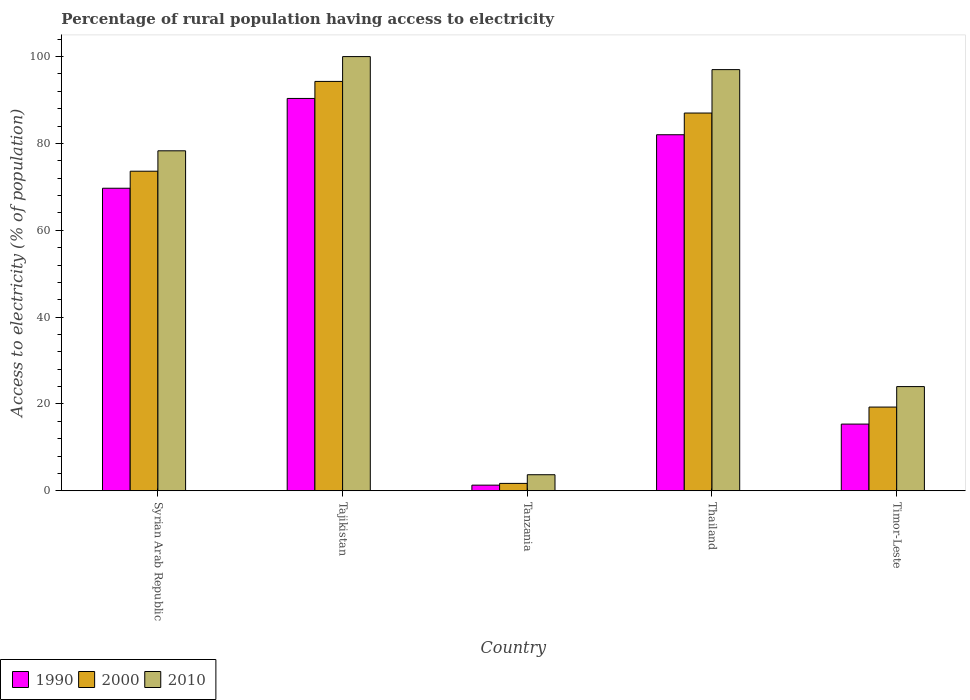How many different coloured bars are there?
Ensure brevity in your answer.  3. How many groups of bars are there?
Make the answer very short. 5. Are the number of bars on each tick of the X-axis equal?
Give a very brief answer. Yes. What is the label of the 1st group of bars from the left?
Offer a terse response. Syrian Arab Republic. In how many cases, is the number of bars for a given country not equal to the number of legend labels?
Your answer should be very brief. 0. What is the percentage of rural population having access to electricity in 2000 in Tajikistan?
Provide a short and direct response. 94.28. Across all countries, what is the maximum percentage of rural population having access to electricity in 1990?
Provide a succinct answer. 90.36. Across all countries, what is the minimum percentage of rural population having access to electricity in 2010?
Offer a very short reply. 3.7. In which country was the percentage of rural population having access to electricity in 2010 maximum?
Provide a short and direct response. Tajikistan. In which country was the percentage of rural population having access to electricity in 2010 minimum?
Ensure brevity in your answer.  Tanzania. What is the total percentage of rural population having access to electricity in 2010 in the graph?
Your answer should be compact. 303. What is the difference between the percentage of rural population having access to electricity in 2010 in Syrian Arab Republic and that in Tanzania?
Your answer should be very brief. 74.6. What is the difference between the percentage of rural population having access to electricity in 2010 in Timor-Leste and the percentage of rural population having access to electricity in 2000 in Syrian Arab Republic?
Your answer should be very brief. -49.6. What is the average percentage of rural population having access to electricity in 2010 per country?
Provide a succinct answer. 60.6. What is the difference between the percentage of rural population having access to electricity of/in 2010 and percentage of rural population having access to electricity of/in 1990 in Tanzania?
Your response must be concise. 2.4. In how many countries, is the percentage of rural population having access to electricity in 2010 greater than 8 %?
Provide a short and direct response. 4. What is the ratio of the percentage of rural population having access to electricity in 2010 in Thailand to that in Timor-Leste?
Ensure brevity in your answer.  4.04. What is the difference between the highest and the second highest percentage of rural population having access to electricity in 2000?
Make the answer very short. -20.68. What is the difference between the highest and the lowest percentage of rural population having access to electricity in 2000?
Keep it short and to the point. 92.58. In how many countries, is the percentage of rural population having access to electricity in 2010 greater than the average percentage of rural population having access to electricity in 2010 taken over all countries?
Your response must be concise. 3. Is the sum of the percentage of rural population having access to electricity in 1990 in Syrian Arab Republic and Timor-Leste greater than the maximum percentage of rural population having access to electricity in 2010 across all countries?
Provide a succinct answer. No. What does the 2nd bar from the right in Syrian Arab Republic represents?
Keep it short and to the point. 2000. Is it the case that in every country, the sum of the percentage of rural population having access to electricity in 1990 and percentage of rural population having access to electricity in 2010 is greater than the percentage of rural population having access to electricity in 2000?
Offer a terse response. Yes. How many countries are there in the graph?
Make the answer very short. 5. What is the difference between two consecutive major ticks on the Y-axis?
Your answer should be compact. 20. Are the values on the major ticks of Y-axis written in scientific E-notation?
Provide a short and direct response. No. Does the graph contain any zero values?
Give a very brief answer. No. Where does the legend appear in the graph?
Offer a terse response. Bottom left. How many legend labels are there?
Provide a succinct answer. 3. How are the legend labels stacked?
Ensure brevity in your answer.  Horizontal. What is the title of the graph?
Offer a terse response. Percentage of rural population having access to electricity. What is the label or title of the Y-axis?
Your answer should be very brief. Access to electricity (% of population). What is the Access to electricity (% of population) of 1990 in Syrian Arab Republic?
Your answer should be compact. 69.68. What is the Access to electricity (% of population) in 2000 in Syrian Arab Republic?
Make the answer very short. 73.6. What is the Access to electricity (% of population) in 2010 in Syrian Arab Republic?
Your answer should be compact. 78.3. What is the Access to electricity (% of population) of 1990 in Tajikistan?
Give a very brief answer. 90.36. What is the Access to electricity (% of population) of 2000 in Tajikistan?
Give a very brief answer. 94.28. What is the Access to electricity (% of population) in 2010 in Tajikistan?
Offer a very short reply. 100. What is the Access to electricity (% of population) in 2010 in Tanzania?
Provide a succinct answer. 3.7. What is the Access to electricity (% of population) of 2000 in Thailand?
Provide a succinct answer. 87. What is the Access to electricity (% of population) of 2010 in Thailand?
Your answer should be compact. 97. What is the Access to electricity (% of population) in 1990 in Timor-Leste?
Your response must be concise. 15.36. What is the Access to electricity (% of population) in 2000 in Timor-Leste?
Offer a terse response. 19.28. Across all countries, what is the maximum Access to electricity (% of population) in 1990?
Make the answer very short. 90.36. Across all countries, what is the maximum Access to electricity (% of population) of 2000?
Keep it short and to the point. 94.28. Across all countries, what is the maximum Access to electricity (% of population) in 2010?
Your answer should be compact. 100. Across all countries, what is the minimum Access to electricity (% of population) of 1990?
Offer a very short reply. 1.3. Across all countries, what is the minimum Access to electricity (% of population) in 2010?
Your answer should be very brief. 3.7. What is the total Access to electricity (% of population) of 1990 in the graph?
Offer a very short reply. 258.7. What is the total Access to electricity (% of population) of 2000 in the graph?
Your answer should be compact. 275.86. What is the total Access to electricity (% of population) of 2010 in the graph?
Your answer should be compact. 303. What is the difference between the Access to electricity (% of population) of 1990 in Syrian Arab Republic and that in Tajikistan?
Offer a very short reply. -20.68. What is the difference between the Access to electricity (% of population) in 2000 in Syrian Arab Republic and that in Tajikistan?
Make the answer very short. -20.68. What is the difference between the Access to electricity (% of population) in 2010 in Syrian Arab Republic and that in Tajikistan?
Give a very brief answer. -21.7. What is the difference between the Access to electricity (% of population) of 1990 in Syrian Arab Republic and that in Tanzania?
Offer a very short reply. 68.38. What is the difference between the Access to electricity (% of population) in 2000 in Syrian Arab Republic and that in Tanzania?
Keep it short and to the point. 71.9. What is the difference between the Access to electricity (% of population) of 2010 in Syrian Arab Republic and that in Tanzania?
Make the answer very short. 74.6. What is the difference between the Access to electricity (% of population) of 1990 in Syrian Arab Republic and that in Thailand?
Give a very brief answer. -12.32. What is the difference between the Access to electricity (% of population) of 2000 in Syrian Arab Republic and that in Thailand?
Provide a short and direct response. -13.4. What is the difference between the Access to electricity (% of population) in 2010 in Syrian Arab Republic and that in Thailand?
Give a very brief answer. -18.7. What is the difference between the Access to electricity (% of population) in 1990 in Syrian Arab Republic and that in Timor-Leste?
Provide a succinct answer. 54.32. What is the difference between the Access to electricity (% of population) in 2000 in Syrian Arab Republic and that in Timor-Leste?
Keep it short and to the point. 54.32. What is the difference between the Access to electricity (% of population) in 2010 in Syrian Arab Republic and that in Timor-Leste?
Offer a terse response. 54.3. What is the difference between the Access to electricity (% of population) of 1990 in Tajikistan and that in Tanzania?
Offer a very short reply. 89.06. What is the difference between the Access to electricity (% of population) of 2000 in Tajikistan and that in Tanzania?
Your answer should be compact. 92.58. What is the difference between the Access to electricity (% of population) of 2010 in Tajikistan and that in Tanzania?
Provide a succinct answer. 96.3. What is the difference between the Access to electricity (% of population) of 1990 in Tajikistan and that in Thailand?
Your answer should be very brief. 8.36. What is the difference between the Access to electricity (% of population) in 2000 in Tajikistan and that in Thailand?
Provide a succinct answer. 7.28. What is the difference between the Access to electricity (% of population) of 2000 in Tajikistan and that in Timor-Leste?
Your answer should be compact. 75. What is the difference between the Access to electricity (% of population) in 1990 in Tanzania and that in Thailand?
Offer a very short reply. -80.7. What is the difference between the Access to electricity (% of population) of 2000 in Tanzania and that in Thailand?
Provide a short and direct response. -85.3. What is the difference between the Access to electricity (% of population) of 2010 in Tanzania and that in Thailand?
Keep it short and to the point. -93.3. What is the difference between the Access to electricity (% of population) in 1990 in Tanzania and that in Timor-Leste?
Your answer should be compact. -14.06. What is the difference between the Access to electricity (% of population) in 2000 in Tanzania and that in Timor-Leste?
Offer a very short reply. -17.58. What is the difference between the Access to electricity (% of population) of 2010 in Tanzania and that in Timor-Leste?
Your response must be concise. -20.3. What is the difference between the Access to electricity (% of population) of 1990 in Thailand and that in Timor-Leste?
Offer a terse response. 66.64. What is the difference between the Access to electricity (% of population) in 2000 in Thailand and that in Timor-Leste?
Give a very brief answer. 67.72. What is the difference between the Access to electricity (% of population) of 2010 in Thailand and that in Timor-Leste?
Make the answer very short. 73. What is the difference between the Access to electricity (% of population) in 1990 in Syrian Arab Republic and the Access to electricity (% of population) in 2000 in Tajikistan?
Provide a succinct answer. -24.6. What is the difference between the Access to electricity (% of population) of 1990 in Syrian Arab Republic and the Access to electricity (% of population) of 2010 in Tajikistan?
Your answer should be compact. -30.32. What is the difference between the Access to electricity (% of population) of 2000 in Syrian Arab Republic and the Access to electricity (% of population) of 2010 in Tajikistan?
Offer a terse response. -26.4. What is the difference between the Access to electricity (% of population) in 1990 in Syrian Arab Republic and the Access to electricity (% of population) in 2000 in Tanzania?
Your response must be concise. 67.98. What is the difference between the Access to electricity (% of population) of 1990 in Syrian Arab Republic and the Access to electricity (% of population) of 2010 in Tanzania?
Your answer should be compact. 65.98. What is the difference between the Access to electricity (% of population) in 2000 in Syrian Arab Republic and the Access to electricity (% of population) in 2010 in Tanzania?
Offer a very short reply. 69.9. What is the difference between the Access to electricity (% of population) of 1990 in Syrian Arab Republic and the Access to electricity (% of population) of 2000 in Thailand?
Your answer should be very brief. -17.32. What is the difference between the Access to electricity (% of population) in 1990 in Syrian Arab Republic and the Access to electricity (% of population) in 2010 in Thailand?
Offer a terse response. -27.32. What is the difference between the Access to electricity (% of population) in 2000 in Syrian Arab Republic and the Access to electricity (% of population) in 2010 in Thailand?
Your answer should be compact. -23.4. What is the difference between the Access to electricity (% of population) of 1990 in Syrian Arab Republic and the Access to electricity (% of population) of 2000 in Timor-Leste?
Keep it short and to the point. 50.4. What is the difference between the Access to electricity (% of population) of 1990 in Syrian Arab Republic and the Access to electricity (% of population) of 2010 in Timor-Leste?
Offer a terse response. 45.68. What is the difference between the Access to electricity (% of population) of 2000 in Syrian Arab Republic and the Access to electricity (% of population) of 2010 in Timor-Leste?
Provide a succinct answer. 49.6. What is the difference between the Access to electricity (% of population) in 1990 in Tajikistan and the Access to electricity (% of population) in 2000 in Tanzania?
Your response must be concise. 88.66. What is the difference between the Access to electricity (% of population) of 1990 in Tajikistan and the Access to electricity (% of population) of 2010 in Tanzania?
Make the answer very short. 86.66. What is the difference between the Access to electricity (% of population) in 2000 in Tajikistan and the Access to electricity (% of population) in 2010 in Tanzania?
Your response must be concise. 90.58. What is the difference between the Access to electricity (% of population) of 1990 in Tajikistan and the Access to electricity (% of population) of 2000 in Thailand?
Keep it short and to the point. 3.36. What is the difference between the Access to electricity (% of population) of 1990 in Tajikistan and the Access to electricity (% of population) of 2010 in Thailand?
Give a very brief answer. -6.64. What is the difference between the Access to electricity (% of population) of 2000 in Tajikistan and the Access to electricity (% of population) of 2010 in Thailand?
Your answer should be compact. -2.72. What is the difference between the Access to electricity (% of population) of 1990 in Tajikistan and the Access to electricity (% of population) of 2000 in Timor-Leste?
Ensure brevity in your answer.  71.08. What is the difference between the Access to electricity (% of population) in 1990 in Tajikistan and the Access to electricity (% of population) in 2010 in Timor-Leste?
Your answer should be compact. 66.36. What is the difference between the Access to electricity (% of population) of 2000 in Tajikistan and the Access to electricity (% of population) of 2010 in Timor-Leste?
Offer a terse response. 70.28. What is the difference between the Access to electricity (% of population) of 1990 in Tanzania and the Access to electricity (% of population) of 2000 in Thailand?
Offer a terse response. -85.7. What is the difference between the Access to electricity (% of population) in 1990 in Tanzania and the Access to electricity (% of population) in 2010 in Thailand?
Ensure brevity in your answer.  -95.7. What is the difference between the Access to electricity (% of population) of 2000 in Tanzania and the Access to electricity (% of population) of 2010 in Thailand?
Your answer should be compact. -95.3. What is the difference between the Access to electricity (% of population) of 1990 in Tanzania and the Access to electricity (% of population) of 2000 in Timor-Leste?
Your response must be concise. -17.98. What is the difference between the Access to electricity (% of population) in 1990 in Tanzania and the Access to electricity (% of population) in 2010 in Timor-Leste?
Provide a succinct answer. -22.7. What is the difference between the Access to electricity (% of population) in 2000 in Tanzania and the Access to electricity (% of population) in 2010 in Timor-Leste?
Your answer should be compact. -22.3. What is the difference between the Access to electricity (% of population) of 1990 in Thailand and the Access to electricity (% of population) of 2000 in Timor-Leste?
Your answer should be very brief. 62.72. What is the average Access to electricity (% of population) in 1990 per country?
Offer a terse response. 51.74. What is the average Access to electricity (% of population) in 2000 per country?
Your response must be concise. 55.17. What is the average Access to electricity (% of population) of 2010 per country?
Keep it short and to the point. 60.6. What is the difference between the Access to electricity (% of population) of 1990 and Access to electricity (% of population) of 2000 in Syrian Arab Republic?
Offer a terse response. -3.92. What is the difference between the Access to electricity (% of population) in 1990 and Access to electricity (% of population) in 2010 in Syrian Arab Republic?
Make the answer very short. -8.62. What is the difference between the Access to electricity (% of population) in 2000 and Access to electricity (% of population) in 2010 in Syrian Arab Republic?
Provide a succinct answer. -4.7. What is the difference between the Access to electricity (% of population) in 1990 and Access to electricity (% of population) in 2000 in Tajikistan?
Your answer should be compact. -3.92. What is the difference between the Access to electricity (% of population) of 1990 and Access to electricity (% of population) of 2010 in Tajikistan?
Your response must be concise. -9.64. What is the difference between the Access to electricity (% of population) in 2000 and Access to electricity (% of population) in 2010 in Tajikistan?
Give a very brief answer. -5.72. What is the difference between the Access to electricity (% of population) in 1990 and Access to electricity (% of population) in 2000 in Tanzania?
Offer a very short reply. -0.4. What is the difference between the Access to electricity (% of population) of 1990 and Access to electricity (% of population) of 2000 in Thailand?
Provide a succinct answer. -5. What is the difference between the Access to electricity (% of population) of 1990 and Access to electricity (% of population) of 2010 in Thailand?
Make the answer very short. -15. What is the difference between the Access to electricity (% of population) of 2000 and Access to electricity (% of population) of 2010 in Thailand?
Your response must be concise. -10. What is the difference between the Access to electricity (% of population) in 1990 and Access to electricity (% of population) in 2000 in Timor-Leste?
Provide a succinct answer. -3.92. What is the difference between the Access to electricity (% of population) in 1990 and Access to electricity (% of population) in 2010 in Timor-Leste?
Make the answer very short. -8.64. What is the difference between the Access to electricity (% of population) in 2000 and Access to electricity (% of population) in 2010 in Timor-Leste?
Make the answer very short. -4.72. What is the ratio of the Access to electricity (% of population) of 1990 in Syrian Arab Republic to that in Tajikistan?
Provide a short and direct response. 0.77. What is the ratio of the Access to electricity (% of population) of 2000 in Syrian Arab Republic to that in Tajikistan?
Your answer should be compact. 0.78. What is the ratio of the Access to electricity (% of population) of 2010 in Syrian Arab Republic to that in Tajikistan?
Make the answer very short. 0.78. What is the ratio of the Access to electricity (% of population) of 1990 in Syrian Arab Republic to that in Tanzania?
Keep it short and to the point. 53.6. What is the ratio of the Access to electricity (% of population) of 2000 in Syrian Arab Republic to that in Tanzania?
Ensure brevity in your answer.  43.29. What is the ratio of the Access to electricity (% of population) in 2010 in Syrian Arab Republic to that in Tanzania?
Make the answer very short. 21.16. What is the ratio of the Access to electricity (% of population) of 1990 in Syrian Arab Republic to that in Thailand?
Your answer should be compact. 0.85. What is the ratio of the Access to electricity (% of population) of 2000 in Syrian Arab Republic to that in Thailand?
Your answer should be compact. 0.85. What is the ratio of the Access to electricity (% of population) of 2010 in Syrian Arab Republic to that in Thailand?
Make the answer very short. 0.81. What is the ratio of the Access to electricity (% of population) of 1990 in Syrian Arab Republic to that in Timor-Leste?
Ensure brevity in your answer.  4.54. What is the ratio of the Access to electricity (% of population) of 2000 in Syrian Arab Republic to that in Timor-Leste?
Give a very brief answer. 3.82. What is the ratio of the Access to electricity (% of population) of 2010 in Syrian Arab Republic to that in Timor-Leste?
Your answer should be very brief. 3.26. What is the ratio of the Access to electricity (% of population) of 1990 in Tajikistan to that in Tanzania?
Offer a very short reply. 69.51. What is the ratio of the Access to electricity (% of population) of 2000 in Tajikistan to that in Tanzania?
Make the answer very short. 55.46. What is the ratio of the Access to electricity (% of population) of 2010 in Tajikistan to that in Tanzania?
Offer a terse response. 27.03. What is the ratio of the Access to electricity (% of population) of 1990 in Tajikistan to that in Thailand?
Your answer should be very brief. 1.1. What is the ratio of the Access to electricity (% of population) in 2000 in Tajikistan to that in Thailand?
Your response must be concise. 1.08. What is the ratio of the Access to electricity (% of population) of 2010 in Tajikistan to that in Thailand?
Give a very brief answer. 1.03. What is the ratio of the Access to electricity (% of population) of 1990 in Tajikistan to that in Timor-Leste?
Provide a short and direct response. 5.88. What is the ratio of the Access to electricity (% of population) of 2000 in Tajikistan to that in Timor-Leste?
Your response must be concise. 4.89. What is the ratio of the Access to electricity (% of population) in 2010 in Tajikistan to that in Timor-Leste?
Make the answer very short. 4.17. What is the ratio of the Access to electricity (% of population) of 1990 in Tanzania to that in Thailand?
Your response must be concise. 0.02. What is the ratio of the Access to electricity (% of population) of 2000 in Tanzania to that in Thailand?
Your response must be concise. 0.02. What is the ratio of the Access to electricity (% of population) of 2010 in Tanzania to that in Thailand?
Your response must be concise. 0.04. What is the ratio of the Access to electricity (% of population) of 1990 in Tanzania to that in Timor-Leste?
Offer a terse response. 0.08. What is the ratio of the Access to electricity (% of population) in 2000 in Tanzania to that in Timor-Leste?
Your response must be concise. 0.09. What is the ratio of the Access to electricity (% of population) of 2010 in Tanzania to that in Timor-Leste?
Provide a succinct answer. 0.15. What is the ratio of the Access to electricity (% of population) of 1990 in Thailand to that in Timor-Leste?
Offer a terse response. 5.34. What is the ratio of the Access to electricity (% of population) of 2000 in Thailand to that in Timor-Leste?
Provide a short and direct response. 4.51. What is the ratio of the Access to electricity (% of population) in 2010 in Thailand to that in Timor-Leste?
Provide a short and direct response. 4.04. What is the difference between the highest and the second highest Access to electricity (% of population) in 1990?
Offer a terse response. 8.36. What is the difference between the highest and the second highest Access to electricity (% of population) in 2000?
Ensure brevity in your answer.  7.28. What is the difference between the highest and the second highest Access to electricity (% of population) in 2010?
Make the answer very short. 3. What is the difference between the highest and the lowest Access to electricity (% of population) of 1990?
Offer a terse response. 89.06. What is the difference between the highest and the lowest Access to electricity (% of population) of 2000?
Make the answer very short. 92.58. What is the difference between the highest and the lowest Access to electricity (% of population) of 2010?
Your response must be concise. 96.3. 